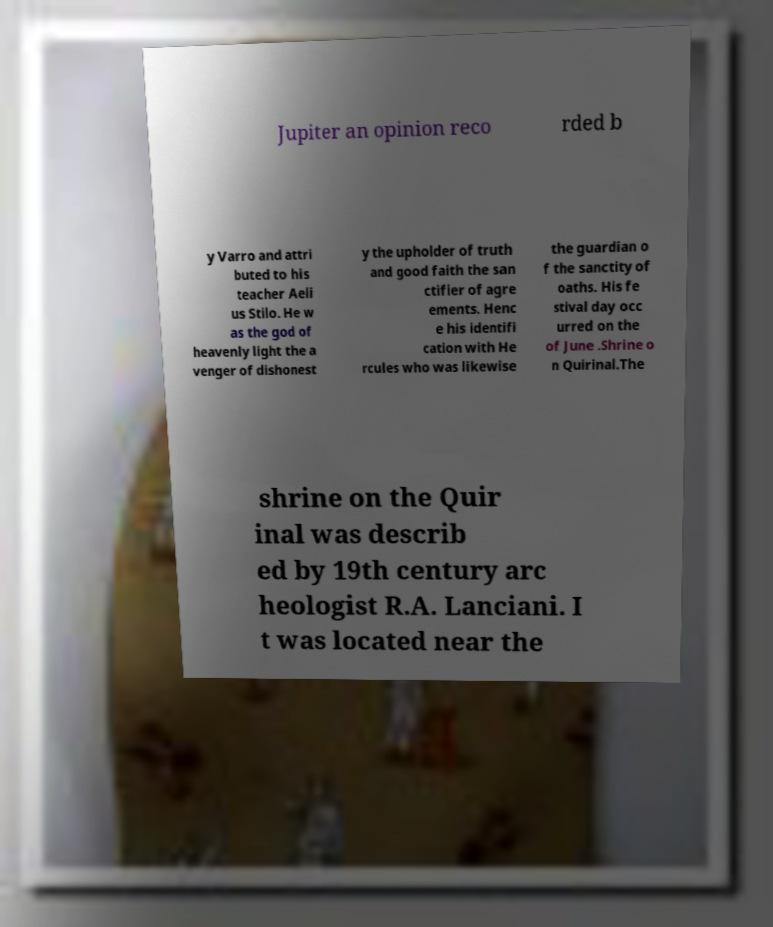Could you extract and type out the text from this image? Jupiter an opinion reco rded b y Varro and attri buted to his teacher Aeli us Stilo. He w as the god of heavenly light the a venger of dishonest y the upholder of truth and good faith the san ctifier of agre ements. Henc e his identifi cation with He rcules who was likewise the guardian o f the sanctity of oaths. His fe stival day occ urred on the of June .Shrine o n Quirinal.The shrine on the Quir inal was describ ed by 19th century arc heologist R.A. Lanciani. I t was located near the 